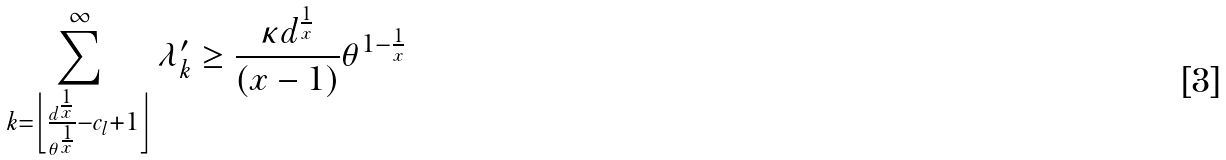Convert formula to latex. <formula><loc_0><loc_0><loc_500><loc_500>\sum _ { k = \left \lfloor \frac { d ^ { \frac { 1 } { x } } } { \theta ^ { \frac { 1 } { x } } } - c _ { l } + 1 \right \rfloor } ^ { \infty } \lambda _ { k } ^ { \prime } \geq \frac { \kappa d ^ { \frac { 1 } { x } } } { ( x - 1 ) } \theta ^ { 1 - \frac { 1 } { x } }</formula> 